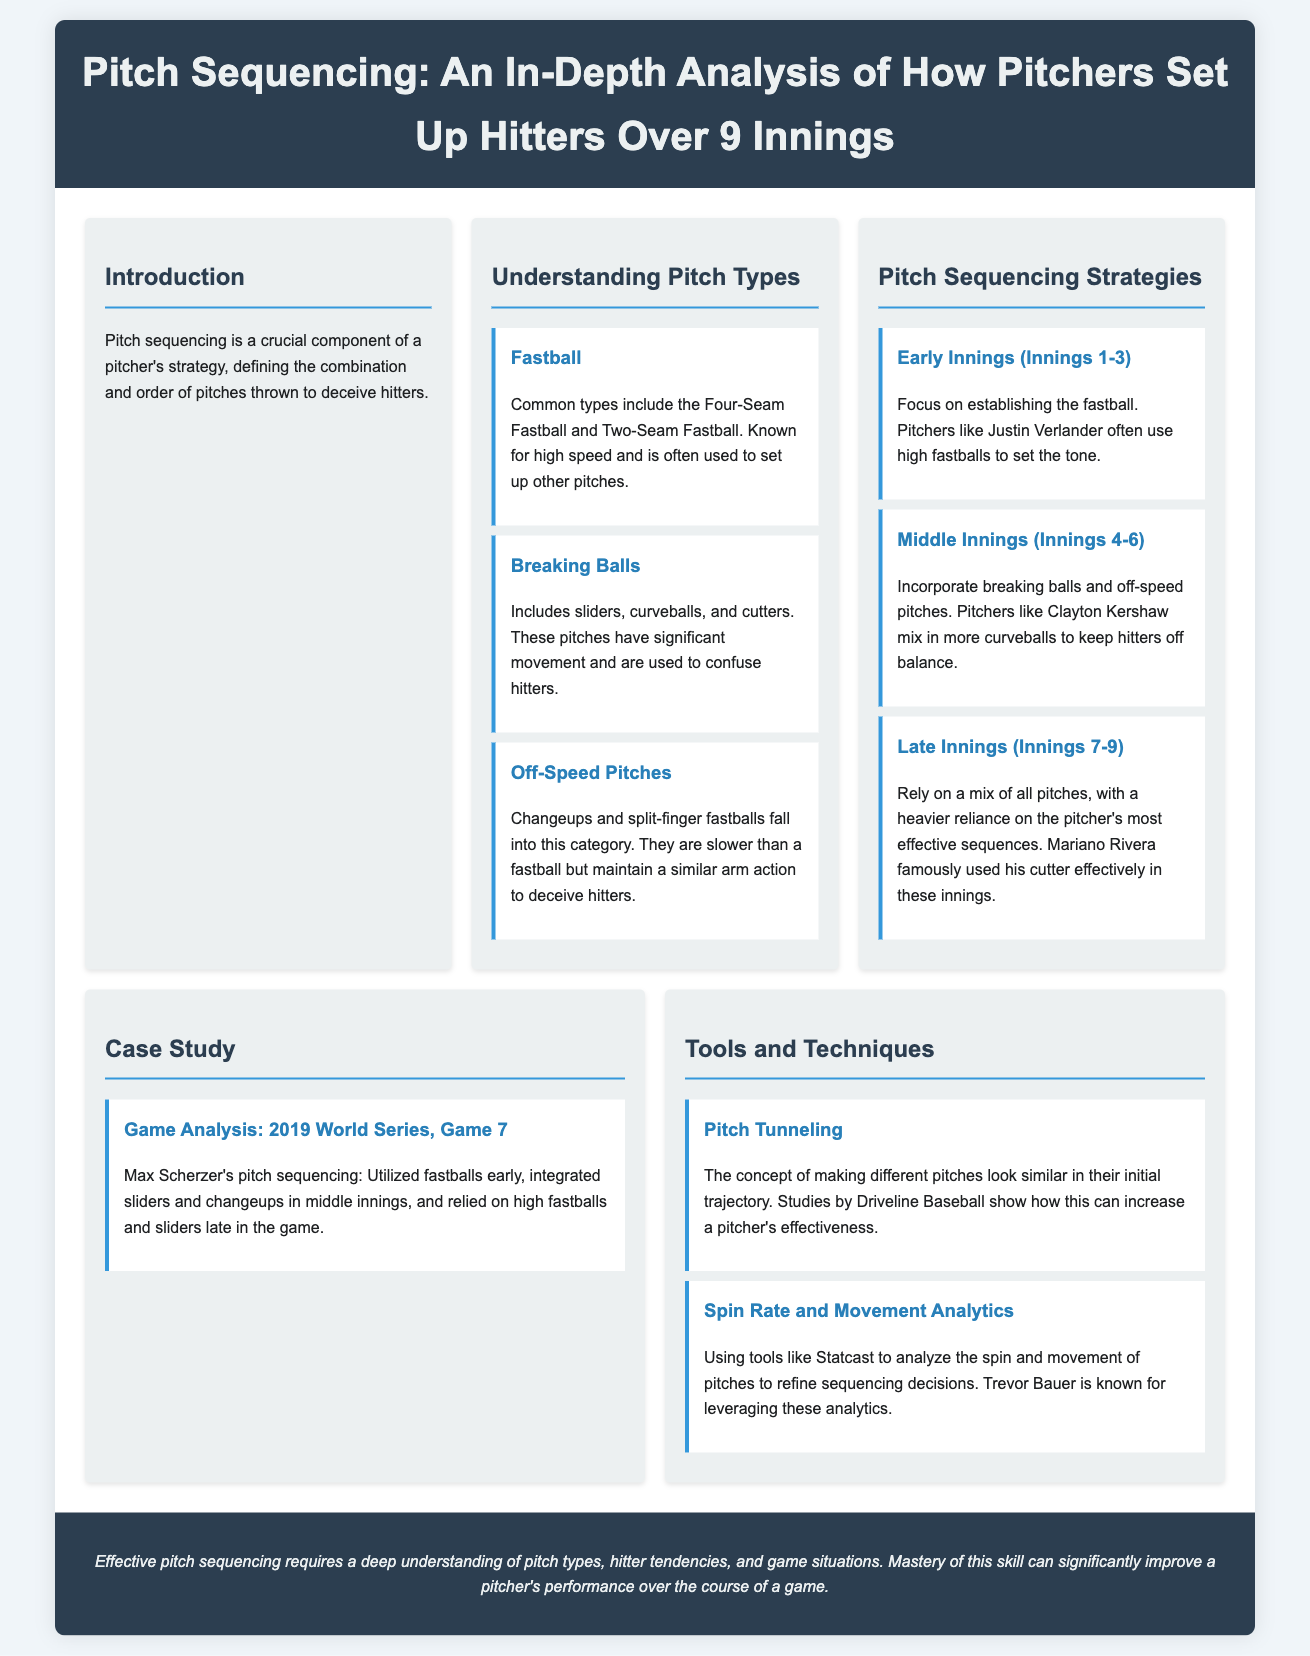What is the primary focus of pitch sequencing? The primary focus of pitch sequencing is to define the combination and order of pitches thrown to deceive hitters.
Answer: Deceiving hitters Which pitcher is known for utilizing high fastballs in early innings? Justin Verlander is mentioned as a pitcher who often uses high fastballs to set the tone in early innings.
Answer: Justin Verlander What pitch types are included in breaking balls? Breaking balls include sliders, curveballs, and cutters.
Answer: Sliders, curveballs, cutters Which innings involve incorporating breaking balls and off-speed pitches? The middle innings (Innings 4-6) involve incorporating breaking balls and off-speed pitches.
Answer: Inning 4-6 What analytics tool is known for analyzing spin rate and movement? Statcast is the tool known for analyzing spin rate and movement.
Answer: Statcast How did Max Scherzer utilize his pitch sequencing in the 2019 World Series? Max Scherzer utilized fastballs early, integrated sliders and changeups in middle innings, and relied on high fastballs and sliders late.
Answer: Fastballs, sliders, changeups What is a key concept in pitch tunneling? The key concept in pitch tunneling is making different pitches look similar in their initial trajectory.
Answer: Similar trajectory What is the conclusion regarding effective pitch sequencing? Effective pitch sequencing requires a deep understanding of pitch types, hitter tendencies, and game situations.
Answer: Deep understanding Which strategy does Mariano Rivera famously rely on in late innings? Mariano Rivera famously relied on his cutter in late innings.
Answer: Cutter 